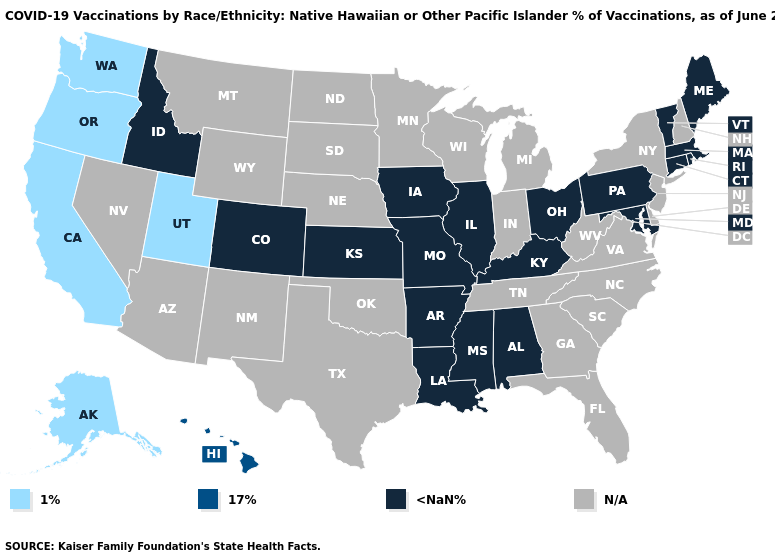What is the lowest value in the Northeast?
Answer briefly. <NaN%. What is the value of Missouri?
Quick response, please. <NaN%. What is the lowest value in the USA?
Write a very short answer. 1%. Does the map have missing data?
Give a very brief answer. Yes. What is the lowest value in the USA?
Concise answer only. 1%. What is the value of Maine?
Concise answer only. <NaN%. Name the states that have a value in the range 1%?
Quick response, please. Alaska, California, Oregon, Utah, Washington. Does Colorado have the lowest value in the West?
Concise answer only. No. What is the value of Wyoming?
Short answer required. N/A. Among the states that border Iowa , which have the lowest value?
Answer briefly. Illinois, Missouri. Among the states that border Nevada , does Idaho have the lowest value?
Answer briefly. No. What is the value of Kansas?
Be succinct. <NaN%. 